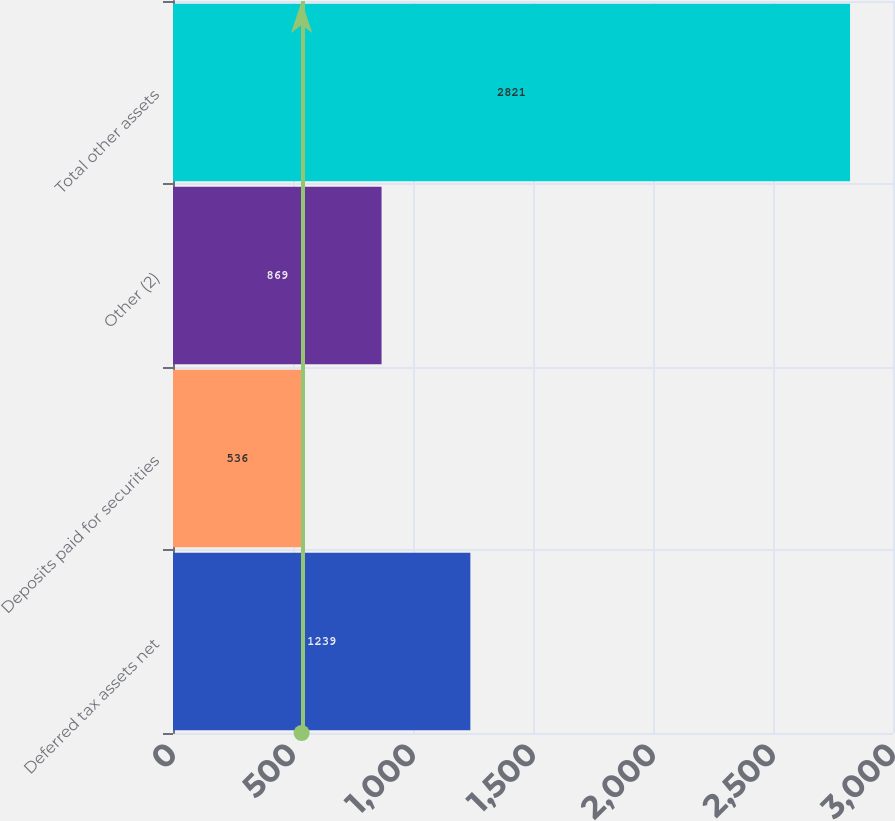Convert chart to OTSL. <chart><loc_0><loc_0><loc_500><loc_500><bar_chart><fcel>Deferred tax assets net<fcel>Deposits paid for securities<fcel>Other (2)<fcel>Total other assets<nl><fcel>1239<fcel>536<fcel>869<fcel>2821<nl></chart> 